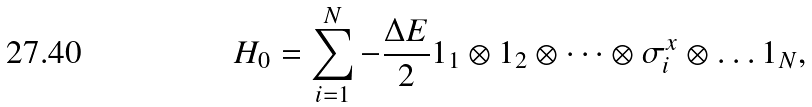Convert formula to latex. <formula><loc_0><loc_0><loc_500><loc_500>H _ { 0 } = \sum _ { i = 1 } ^ { N } - \frac { \Delta E } { 2 } 1 _ { 1 } \otimes 1 _ { 2 } \otimes \dots \otimes \sigma ^ { x } _ { i } \otimes \dots 1 _ { N } ,</formula> 